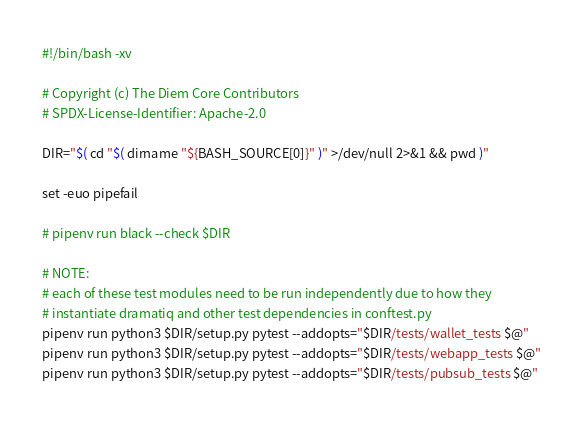<code> <loc_0><loc_0><loc_500><loc_500><_Bash_>#!/bin/bash -xv

# Copyright (c) The Diem Core Contributors
# SPDX-License-Identifier: Apache-2.0

DIR="$( cd "$( dirname "${BASH_SOURCE[0]}" )" >/dev/null 2>&1 && pwd )"

set -euo pipefail

# pipenv run black --check $DIR

# NOTE:
# each of these test modules need to be run independently due to how they
# instantiate dramatiq and other test dependencies in conftest.py
pipenv run python3 $DIR/setup.py pytest --addopts="$DIR/tests/wallet_tests $@"
pipenv run python3 $DIR/setup.py pytest --addopts="$DIR/tests/webapp_tests $@"
pipenv run python3 $DIR/setup.py pytest --addopts="$DIR/tests/pubsub_tests $@"</code> 